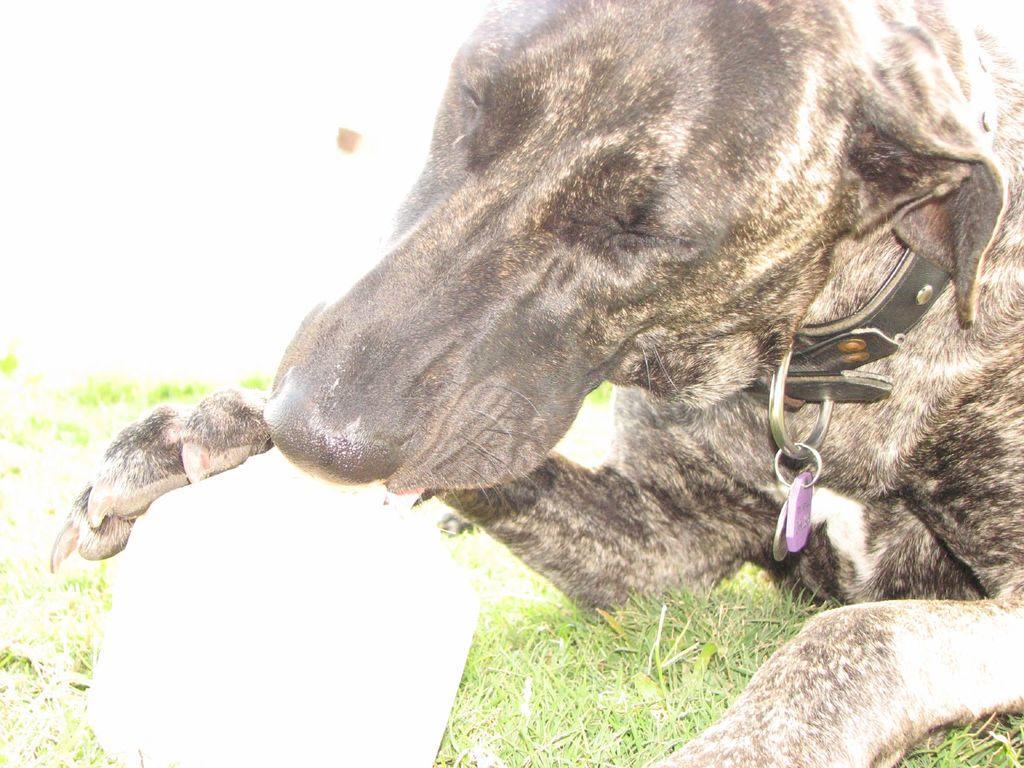Describe this image in one or two sentences. In this picture I can see a black color dog. The dog is wearing a collar neck belt. On the left side I can see grass and a white color object. 